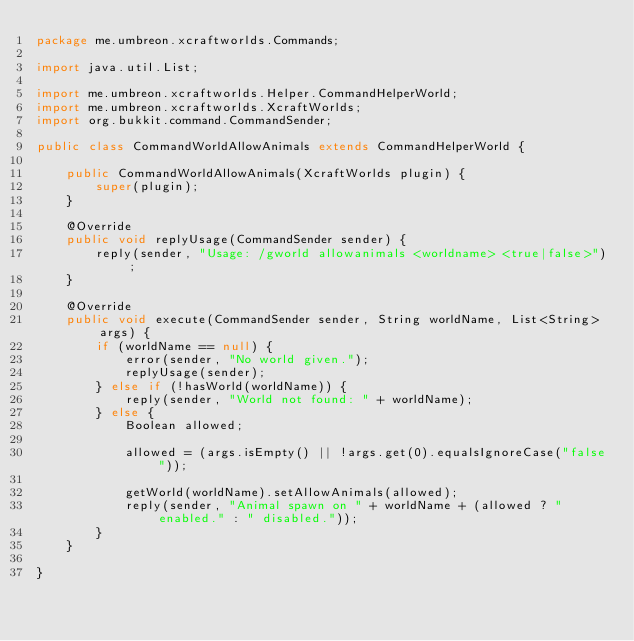<code> <loc_0><loc_0><loc_500><loc_500><_Java_>package me.umbreon.xcraftworlds.Commands;

import java.util.List;

import me.umbreon.xcraftworlds.Helper.CommandHelperWorld;
import me.umbreon.xcraftworlds.XcraftWorlds;
import org.bukkit.command.CommandSender;

public class CommandWorldAllowAnimals extends CommandHelperWorld {

    public CommandWorldAllowAnimals(XcraftWorlds plugin) {
        super(plugin);
    }

    @Override
    public void replyUsage(CommandSender sender) {
        reply(sender, "Usage: /gworld allowanimals <worldname> <true|false>");
    }

    @Override
    public void execute(CommandSender sender, String worldName, List<String> args) {
        if (worldName == null) {
            error(sender, "No world given.");
            replyUsage(sender);
        } else if (!hasWorld(worldName)) {
            reply(sender, "World not found: " + worldName);
        } else {
            Boolean allowed;

            allowed = (args.isEmpty() || !args.get(0).equalsIgnoreCase("false"));

            getWorld(worldName).setAllowAnimals(allowed);
            reply(sender, "Animal spawn on " + worldName + (allowed ? " enabled." : " disabled."));
        }
    }

}
</code> 